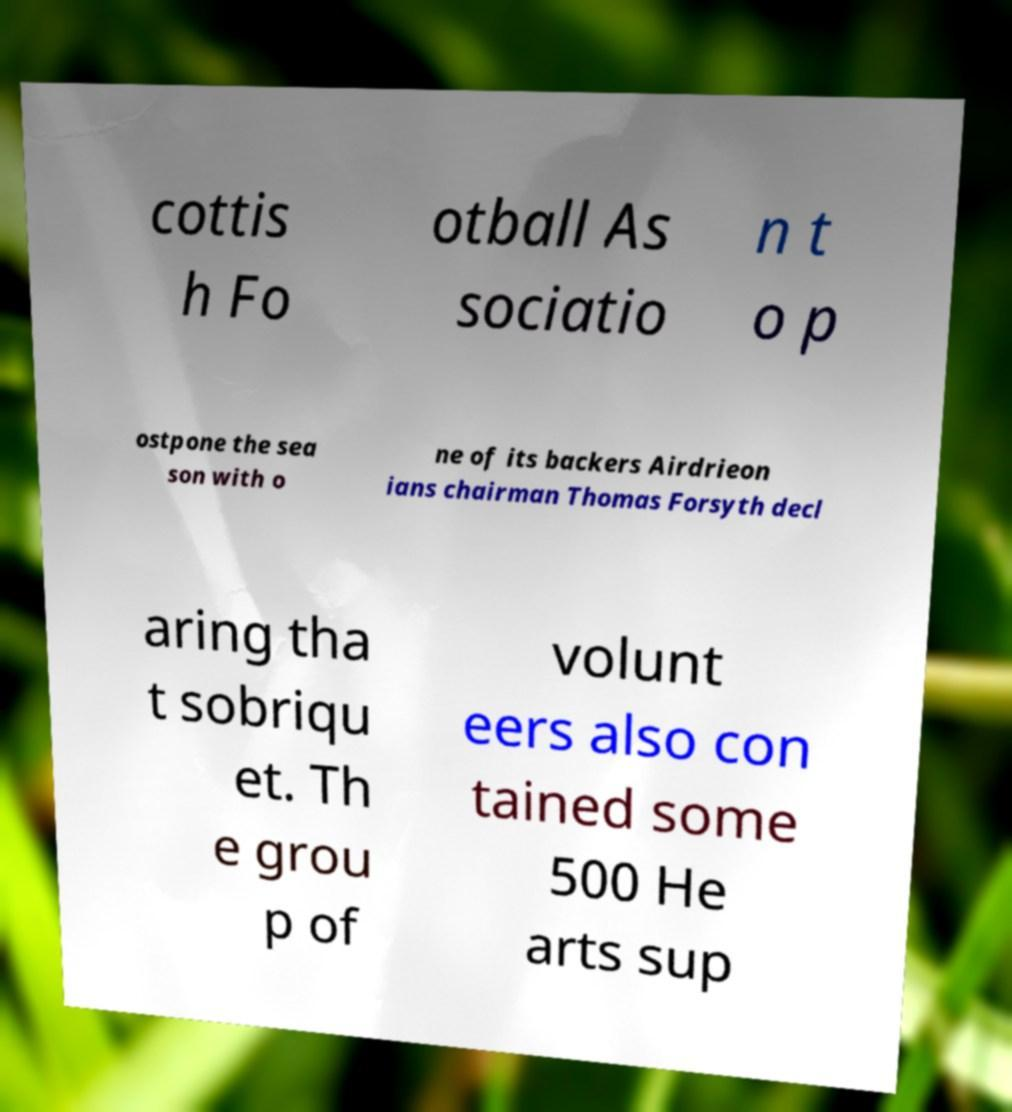Please read and relay the text visible in this image. What does it say? cottis h Fo otball As sociatio n t o p ostpone the sea son with o ne of its backers Airdrieon ians chairman Thomas Forsyth decl aring tha t sobriqu et. Th e grou p of volunt eers also con tained some 500 He arts sup 